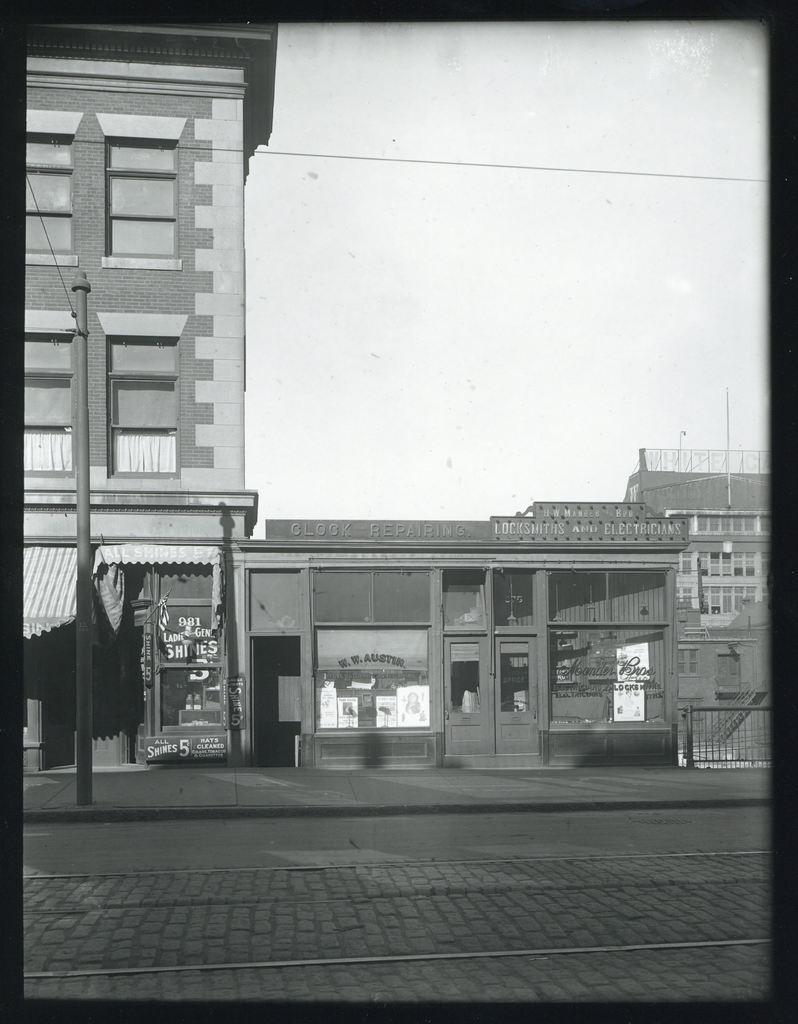Describe this image in one or two sentences. This is a black and white picture, there are buildings in the back with a road in front of it and above its sky. 